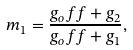Convert formula to latex. <formula><loc_0><loc_0><loc_500><loc_500>m _ { 1 } = \frac { g _ { o } f f + g _ { 2 } } { g _ { o } f f + g _ { 1 } } ,</formula> 